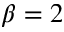<formula> <loc_0><loc_0><loc_500><loc_500>\beta = 2</formula> 